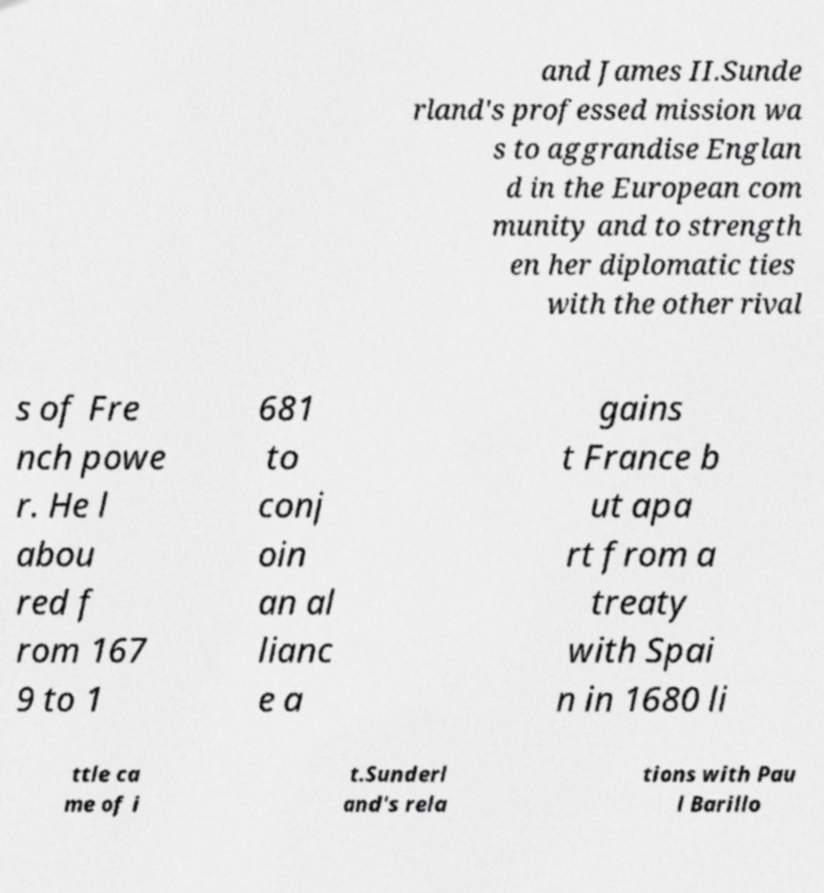Could you extract and type out the text from this image? and James II.Sunde rland's professed mission wa s to aggrandise Englan d in the European com munity and to strength en her diplomatic ties with the other rival s of Fre nch powe r. He l abou red f rom 167 9 to 1 681 to conj oin an al lianc e a gains t France b ut apa rt from a treaty with Spai n in 1680 li ttle ca me of i t.Sunderl and's rela tions with Pau l Barillo 